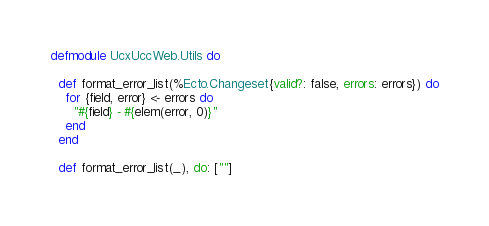<code> <loc_0><loc_0><loc_500><loc_500><_Elixir_>defmodule UcxUccWeb.Utils do

  def format_error_list(%Ecto.Changeset{valid?: false, errors: errors}) do
    for {field, error} <- errors do
      "#{field} - #{elem(error, 0)}"
    end
  end

  def format_error_list(_), do: [""]
</code> 